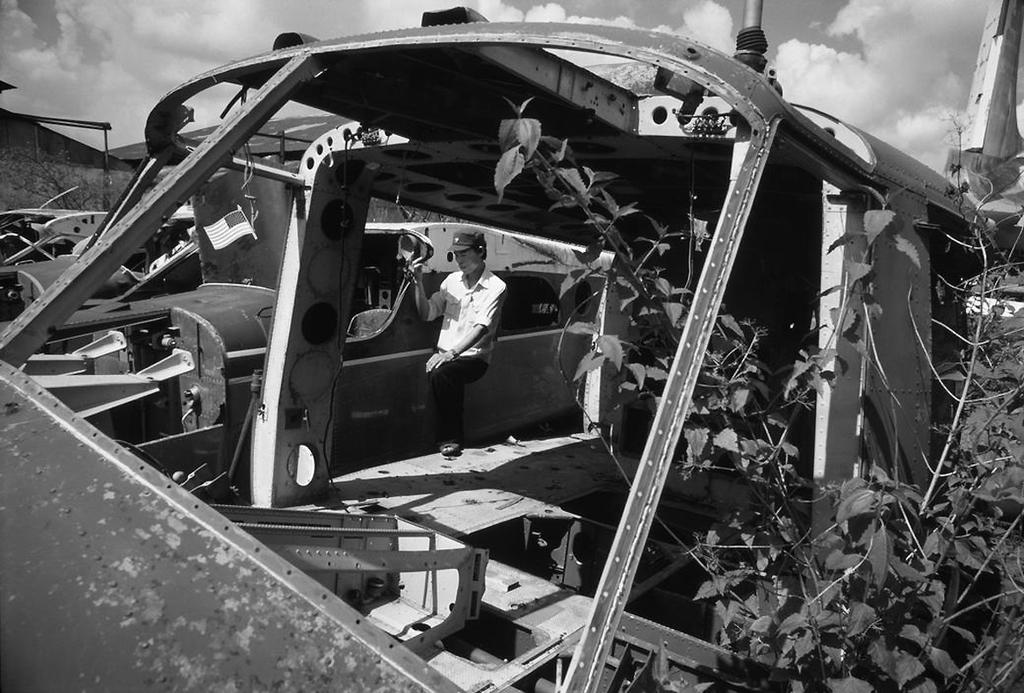What type of vehicles can be seen in the image? There are old vehicles in the image. Can you describe the person in the image? The person is standing in the image and is wearing a cap. What can be seen on the right side of the image? There are plants on the right side of the image. What structures are visible in the background of the image? There is a shed and a tree in the background of the image. How would you describe the weather in the image? The sky is cloudy in the background of the image, suggesting a potentially overcast or cloudy day. Where is the cemetery located in the image? There is no cemetery present in the image. What type of house is visible in the background of the image? There is no house visible in the image; only a shed and a tree are present in the background. 